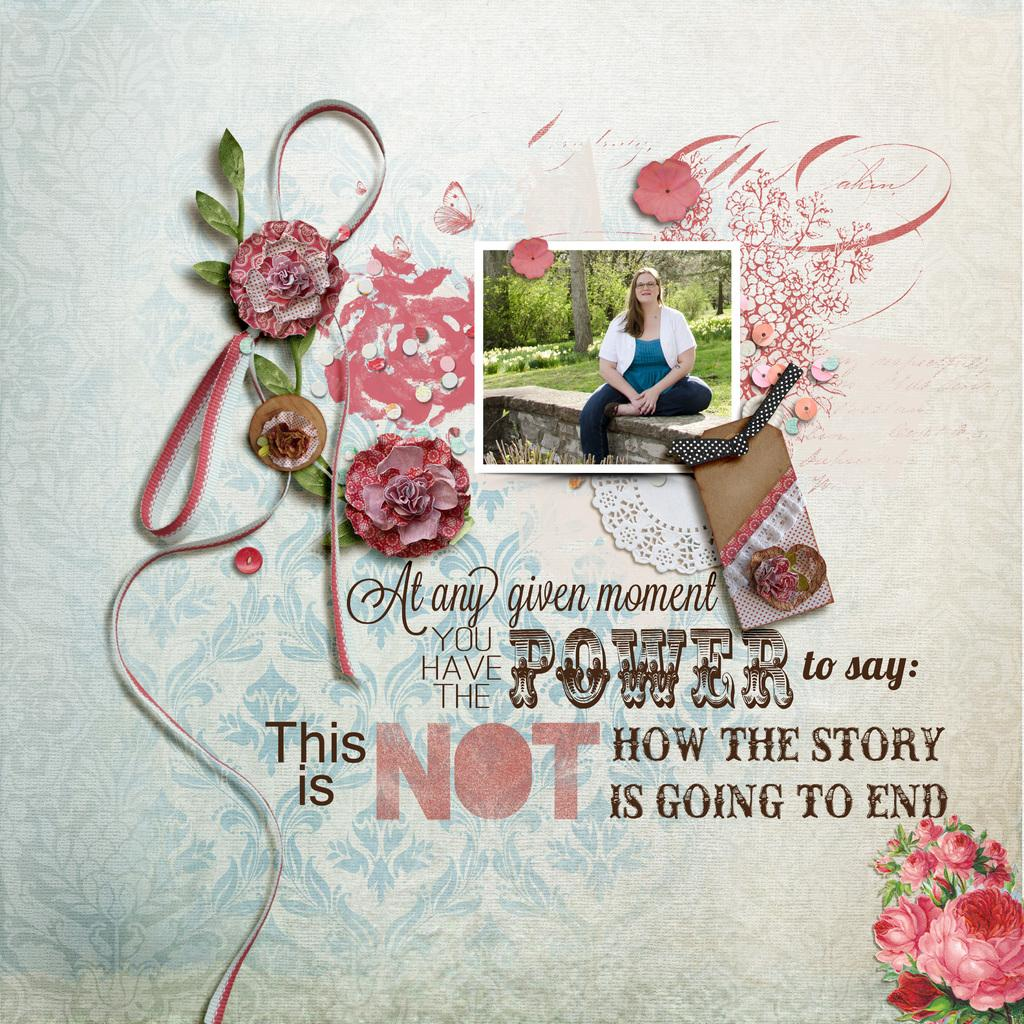What is the nature of the image? The image is edited and animated. What can be found in the image besides the woman and trees? There is text written in the image, and there is grass on the ground. How is the woman depicted in the image? The woman is sitting and smiling in the image. What type of environment is shown in the image? The image features trees and grass, suggesting a natural setting. What type of cake is being pushed by the woman in the image? There is no cake present in the image, nor is the woman pushing anything. What is the woman using to carry water in the image? There is no pail or any indication of carrying water in the image. 